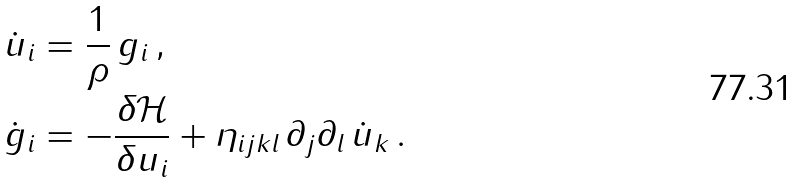<formula> <loc_0><loc_0><loc_500><loc_500>\dot { u } _ { i } & = \frac { 1 } { \rho } \, g _ { i } \, , \\ \dot { g } _ { i } & = - \frac { \delta \mathcal { H } } { \delta u _ { i } } + \eta _ { i j k l } \, \partial _ { j } \partial _ { l } \, \dot { u } _ { k } \, .</formula> 